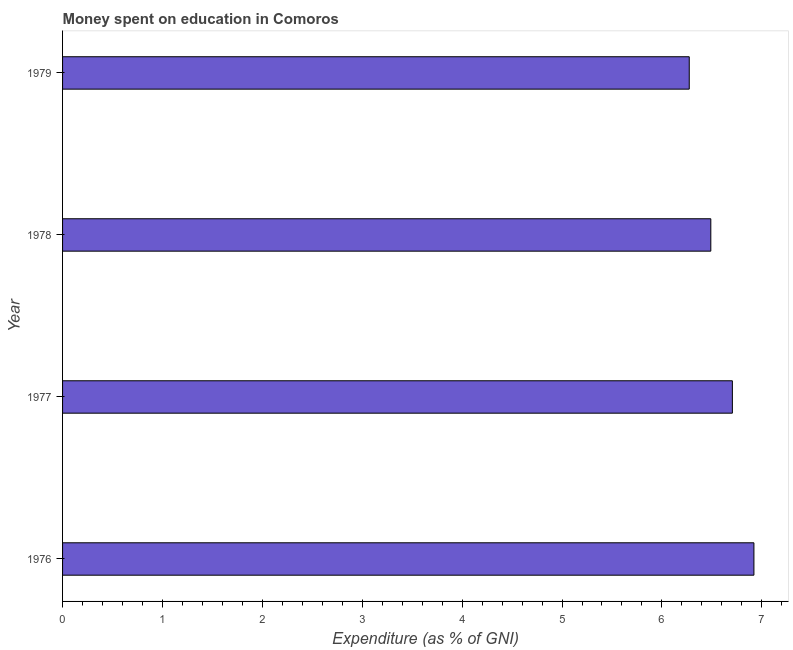Does the graph contain grids?
Offer a very short reply. No. What is the title of the graph?
Offer a very short reply. Money spent on education in Comoros. What is the label or title of the X-axis?
Offer a very short reply. Expenditure (as % of GNI). What is the expenditure on education in 1977?
Your answer should be very brief. 6.71. Across all years, what is the maximum expenditure on education?
Make the answer very short. 6.92. Across all years, what is the minimum expenditure on education?
Offer a terse response. 6.27. In which year was the expenditure on education maximum?
Provide a succinct answer. 1976. In which year was the expenditure on education minimum?
Provide a succinct answer. 1979. What is the sum of the expenditure on education?
Ensure brevity in your answer.  26.39. What is the difference between the expenditure on education in 1976 and 1977?
Provide a succinct answer. 0.22. What is the average expenditure on education per year?
Your answer should be compact. 6.6. What is the median expenditure on education?
Offer a terse response. 6.6. Do a majority of the years between 1977 and 1978 (inclusive) have expenditure on education greater than 2.4 %?
Offer a terse response. Yes. What is the ratio of the expenditure on education in 1978 to that in 1979?
Your response must be concise. 1.03. Is the expenditure on education in 1978 less than that in 1979?
Offer a terse response. No. Is the difference between the expenditure on education in 1977 and 1979 greater than the difference between any two years?
Ensure brevity in your answer.  No. What is the difference between the highest and the second highest expenditure on education?
Provide a short and direct response. 0.22. What is the difference between the highest and the lowest expenditure on education?
Your answer should be very brief. 0.65. How many bars are there?
Provide a succinct answer. 4. Are all the bars in the graph horizontal?
Your answer should be very brief. Yes. What is the difference between two consecutive major ticks on the X-axis?
Make the answer very short. 1. Are the values on the major ticks of X-axis written in scientific E-notation?
Your answer should be compact. No. What is the Expenditure (as % of GNI) in 1976?
Offer a very short reply. 6.92. What is the Expenditure (as % of GNI) in 1977?
Provide a succinct answer. 6.71. What is the Expenditure (as % of GNI) in 1978?
Your response must be concise. 6.49. What is the Expenditure (as % of GNI) in 1979?
Provide a short and direct response. 6.27. What is the difference between the Expenditure (as % of GNI) in 1976 and 1977?
Make the answer very short. 0.22. What is the difference between the Expenditure (as % of GNI) in 1976 and 1978?
Your answer should be compact. 0.43. What is the difference between the Expenditure (as % of GNI) in 1976 and 1979?
Give a very brief answer. 0.65. What is the difference between the Expenditure (as % of GNI) in 1977 and 1978?
Your response must be concise. 0.22. What is the difference between the Expenditure (as % of GNI) in 1977 and 1979?
Your answer should be very brief. 0.43. What is the difference between the Expenditure (as % of GNI) in 1978 and 1979?
Ensure brevity in your answer.  0.22. What is the ratio of the Expenditure (as % of GNI) in 1976 to that in 1977?
Ensure brevity in your answer.  1.03. What is the ratio of the Expenditure (as % of GNI) in 1976 to that in 1978?
Keep it short and to the point. 1.07. What is the ratio of the Expenditure (as % of GNI) in 1976 to that in 1979?
Offer a terse response. 1.1. What is the ratio of the Expenditure (as % of GNI) in 1977 to that in 1978?
Ensure brevity in your answer.  1.03. What is the ratio of the Expenditure (as % of GNI) in 1977 to that in 1979?
Make the answer very short. 1.07. What is the ratio of the Expenditure (as % of GNI) in 1978 to that in 1979?
Ensure brevity in your answer.  1.03. 